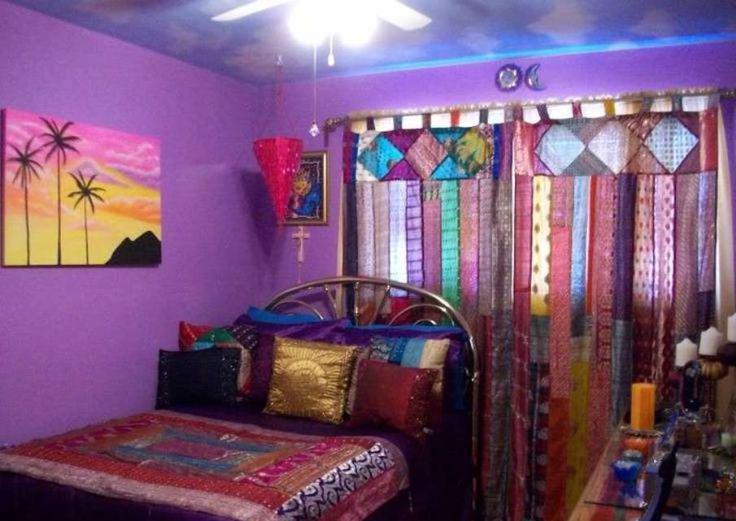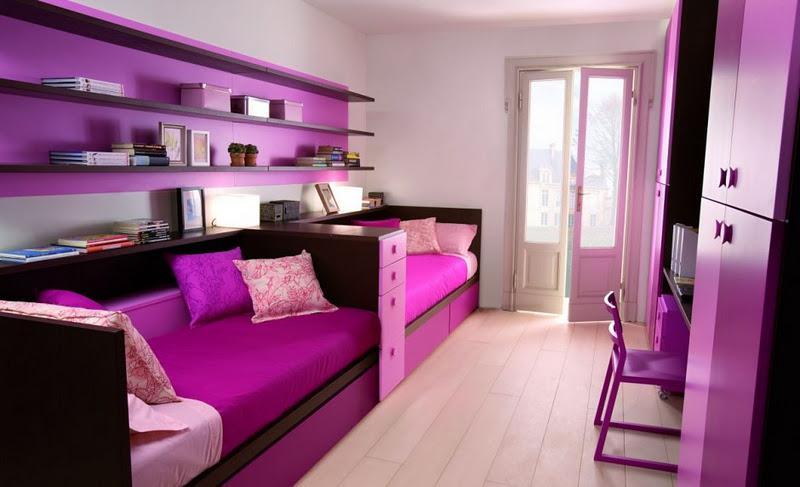The first image is the image on the left, the second image is the image on the right. For the images displayed, is the sentence "Bright purple pillows sit on at least one of the beds." factually correct? Answer yes or no. Yes. The first image is the image on the left, the second image is the image on the right. For the images shown, is this caption "One image shows a ceiling-suspended gauzy canopy over a bed." true? Answer yes or no. No. 